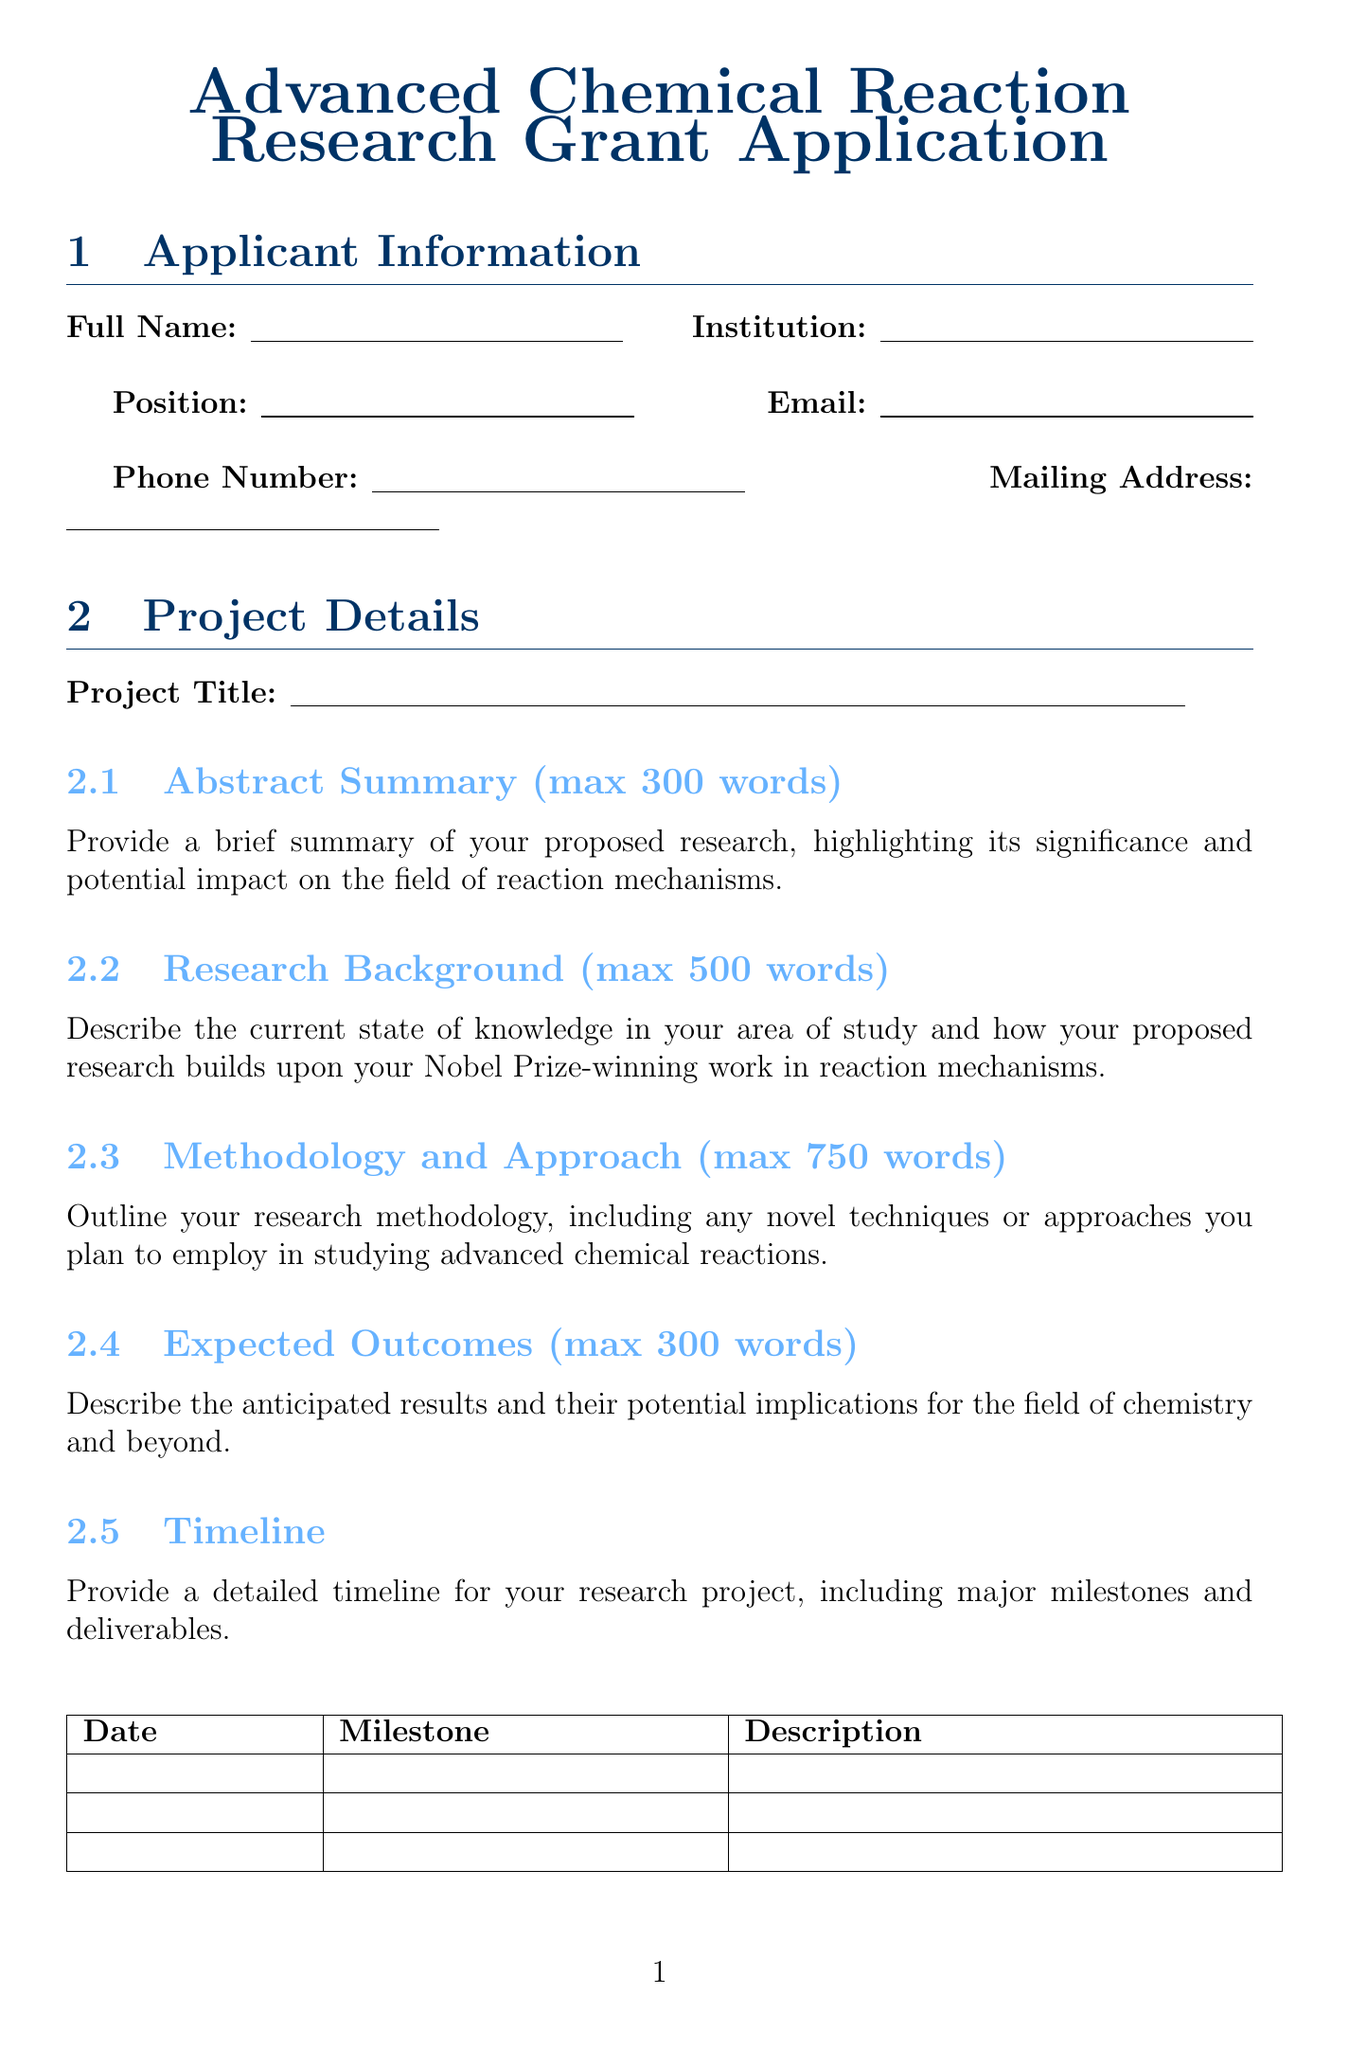What is the project title? The project title is found in the project details section of the document, where it is specified to capture the essence of the proposed research.
Answer: [Leave blank in the rendered document] What is the email of the applicant? The email is listed in the applicant information section, where contact details are specified for the primary investigator.
Answer: [Leave blank in the rendered document] What is the estimated cost for the Bruker 600 MHz NMR Spectrometer? The estimated cost for this equipment is found in the budget breakdown section, specifically under equipment costs, while the justification explains its necessity.
Answer: [Leave blank in the rendered document] How many words is allowed for the research background description? This information can be found in the project details section, which specifies a maximum word count to ensure conciseness and focus on essential information.
Answer: 500 What is the reason for attending the American Chemical Society National Meeting? The record for travel costs includes purposes for travelling, which is necessary to support collaboration and dissemination of research findings effectively.
Answer: Attendance at American Chemical Society National Meeting What percentage range is typical for indirect costs? The document specifies a typical range in the indirect costs section to highlight the overhead related to the research institution and its budget considerations.
Answer: 50-60% What is the total budget requested? This field is found towards the end of the budget breakdown, illustrating the overall financial need for the proposed project.
Answer: [Leave blank in the rendered document] Which journals are mentioned for publication costs? The estimated publication costs include specified high-impact journals known for disseminating significant findings in chemistry.
Answer: Nature Chemistry and Journal of the American Chemical Society What is the purpose of the ethics statement? This information is found in the additional information section, which outlines the necessity of addressing ethical considerations and safety protocols related to the proposed research.
Answer: Ethical considerations related to proposed research 